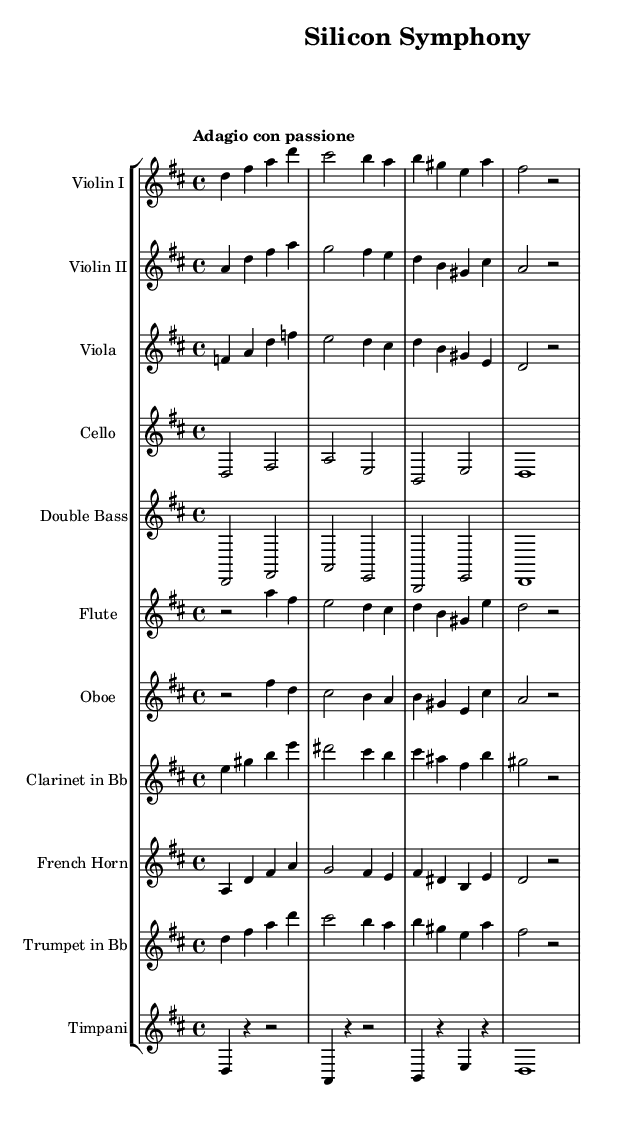What is the key signature of this music? The key signature has two sharps, which corresponds to the D major scale. It can be identified by looking at the beginning of the staff where the sharps are notated.
Answer: D major What is the time signature of this piece? The time signature is located at the beginning of the staff. Here, it is marked as 4/4, indicating four beats per measure.
Answer: 4/4 What is the tempo marking for "Silicon Symphony"? The tempo marking is found at the start of the score, which describes the speed of the piece. It states "Adagio con passione," indicating a slower tempo with passionate execution.
Answer: Adagio con passione Which instrument has the highest pitch range in this orchestral piece? To determine the highest pitch, we look at the individual staves and identify the ranges of the instruments. The flute is typically set in a higher register and plays notes an octave above the strings, thus it has the highest pitch range overall.
Answer: Flute How many instruments are featured in "Silicon Symphony"? The number of instruments can be counted by reviewing how many different staves are notated in the score. Here, there are ten distinct staves, each representing a different instrument.
Answer: Ten What type of orchestral piece does "Silicon Symphony" represent based on its characteristics? Analyzing the characteristics such as the serene tempo, lush harmonies, and expressive lines, we can identify that this orchestral work embodies elements typical of Romantic orchestral music, which often celebrates innovation and feelings.
Answer: Romantic orchestral 